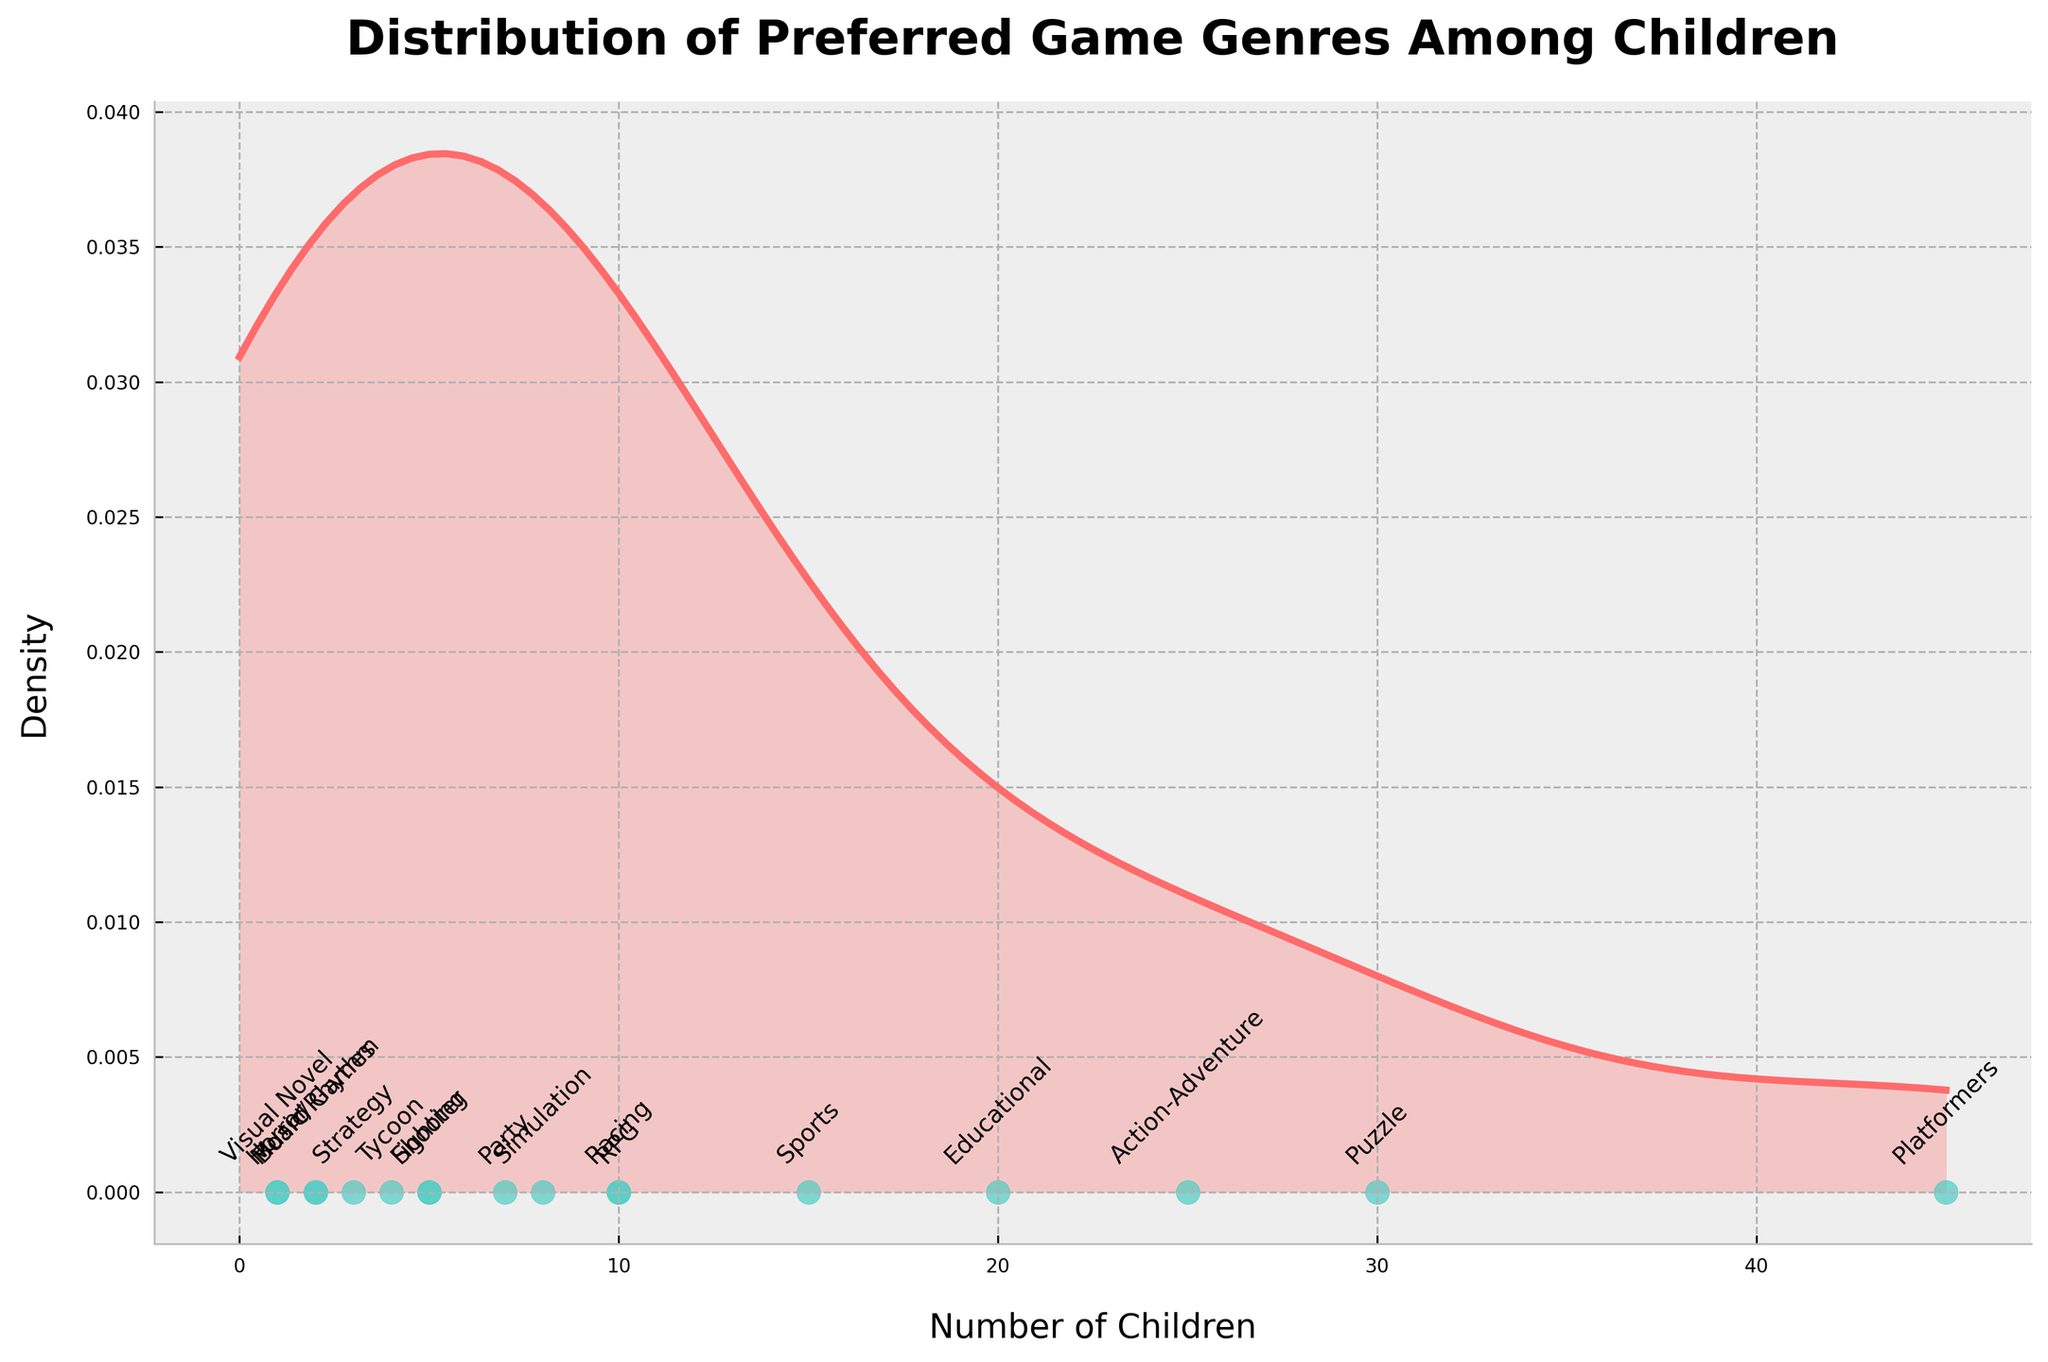What is the title of the plot? The title of the plot is located at the top and reads "Distribution of Preferred Game Genres Among Children".
Answer: Distribution of Preferred Game Genres Among Children How many genres are represented in the plot? Each genre is marked with an annotation along the horizontal axis; counting these annotations gives us 17 genres.
Answer: 17 Which genre has the highest count of children? The vertical axis represents density, and the horizontal axis represents the number of children. Identifying the highest point on the scatter plot and reading the corresponding annotation shows "Platformers" with 45 children.
Answer: Platformers What is the range of the number of children who prefer different game genres? The range can be determined by identifying the smallest and largest counts in the plot. The smallest count is for "Horror" and "Visual Novel" with 1 child each, and the largest is "Platformers" with 45 children. Thus, the range is 45 - 1.
Answer: 44 What is the total number of children who participated in the survey? To find the total, sum the counts shown in the scatter points: 45 + 30 + 25 + 20 + 15 + 10 + 10 + 8 + 7 + 5 + 5 + 4 + 3 + 2 + 2 + 1 + 1 = 173.
Answer: 173 Which genre has the least density of preference among children? The density is represented by the vertical axis. The genres "Horror" and "Visual Novel" each has the lowest count of children (1). Therefore, their density will be the least.
Answer: Horror, Visual Novel Compare the number of children preferring "Puzzle" and "Racing" genres. How many more children prefer "Puzzle" over "Racing"? The counts for "Puzzle" and "Racing" are 30 and 10, respectively. Subtracting these gives: 30 - 10 = 20.
Answer: 20 What's the cumulative count of children preferring "Action-Adventure", "RPG", and "Simulation" genres? Summing the counts for these genres: 25 (Action-Adventure) + 10 (RPG) + 8 (Simulation) = 43.
Answer: 43 Which genre lies in the middle in terms of preference count? To find the median, sort the genres by count and find the middle value. The sorted counts are [1, 1, 2, 2, 3, 4, 5, 5, 7, 8, 10, 10, 15, 20, 25, 30, 45]. The median is the middle value in this sorted list, which is 8, corresponding to "Simulation".
Answer: Simulation 